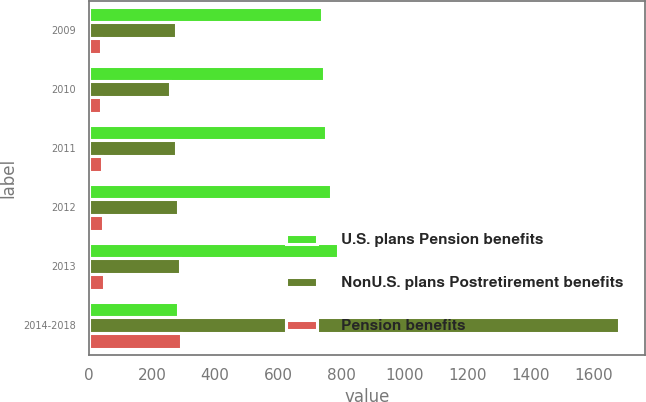<chart> <loc_0><loc_0><loc_500><loc_500><stacked_bar_chart><ecel><fcel>2009<fcel>2010<fcel>2011<fcel>2012<fcel>2013<fcel>2014-2018<nl><fcel>U.S. plans Pension benefits<fcel>740<fcel>745<fcel>752<fcel>769<fcel>789<fcel>284<nl><fcel>NonU.S. plans Postretirement benefits<fcel>276<fcel>258<fcel>275<fcel>284<fcel>288<fcel>1680<nl><fcel>Pension benefits<fcel>37<fcel>39<fcel>41<fcel>44<fcel>47<fcel>291<nl></chart> 